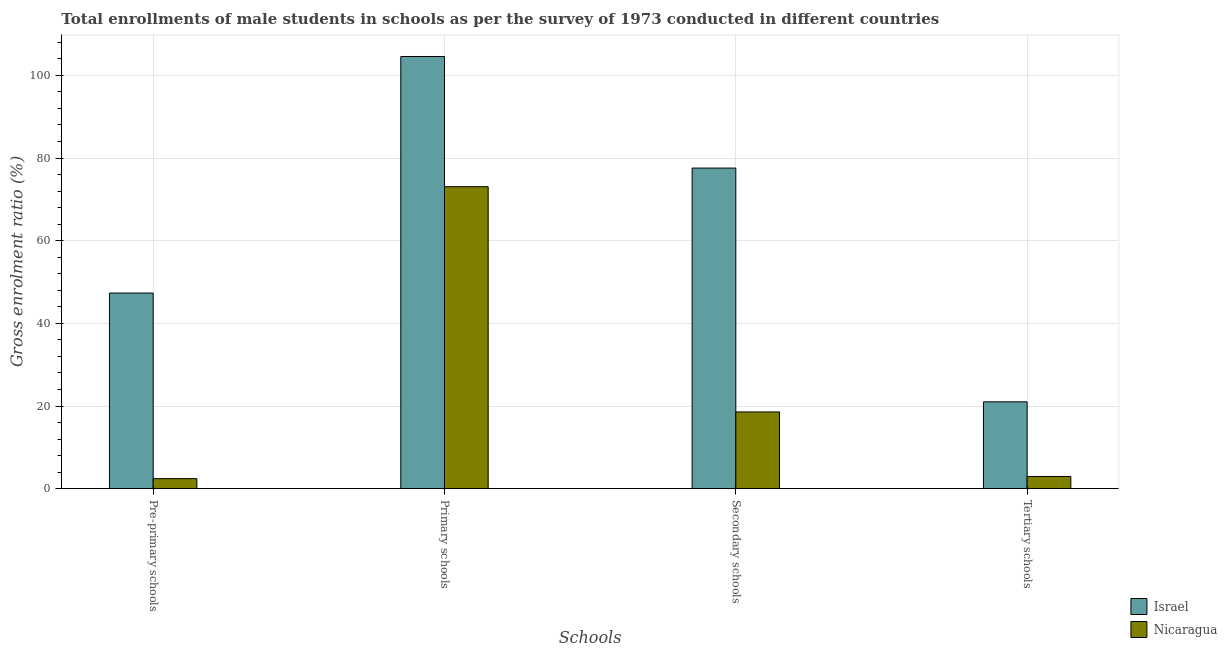How many different coloured bars are there?
Provide a succinct answer. 2. How many groups of bars are there?
Make the answer very short. 4. How many bars are there on the 1st tick from the left?
Your answer should be compact. 2. What is the label of the 1st group of bars from the left?
Your answer should be compact. Pre-primary schools. What is the gross enrolment ratio(male) in tertiary schools in Nicaragua?
Ensure brevity in your answer.  2.95. Across all countries, what is the maximum gross enrolment ratio(male) in primary schools?
Offer a terse response. 104.57. Across all countries, what is the minimum gross enrolment ratio(male) in primary schools?
Make the answer very short. 73.07. In which country was the gross enrolment ratio(male) in pre-primary schools maximum?
Offer a very short reply. Israel. In which country was the gross enrolment ratio(male) in secondary schools minimum?
Your answer should be compact. Nicaragua. What is the total gross enrolment ratio(male) in primary schools in the graph?
Provide a short and direct response. 177.64. What is the difference between the gross enrolment ratio(male) in pre-primary schools in Nicaragua and that in Israel?
Your response must be concise. -44.91. What is the difference between the gross enrolment ratio(male) in secondary schools in Nicaragua and the gross enrolment ratio(male) in pre-primary schools in Israel?
Ensure brevity in your answer.  -28.77. What is the average gross enrolment ratio(male) in primary schools per country?
Ensure brevity in your answer.  88.82. What is the difference between the gross enrolment ratio(male) in pre-primary schools and gross enrolment ratio(male) in tertiary schools in Nicaragua?
Offer a very short reply. -0.52. What is the ratio of the gross enrolment ratio(male) in pre-primary schools in Nicaragua to that in Israel?
Make the answer very short. 0.05. What is the difference between the highest and the second highest gross enrolment ratio(male) in pre-primary schools?
Provide a short and direct response. 44.91. What is the difference between the highest and the lowest gross enrolment ratio(male) in secondary schools?
Ensure brevity in your answer.  59.01. In how many countries, is the gross enrolment ratio(male) in primary schools greater than the average gross enrolment ratio(male) in primary schools taken over all countries?
Offer a terse response. 1. Is the sum of the gross enrolment ratio(male) in primary schools in Israel and Nicaragua greater than the maximum gross enrolment ratio(male) in secondary schools across all countries?
Your response must be concise. Yes. What does the 2nd bar from the left in Tertiary schools represents?
Give a very brief answer. Nicaragua. What does the 1st bar from the right in Pre-primary schools represents?
Your response must be concise. Nicaragua. Is it the case that in every country, the sum of the gross enrolment ratio(male) in pre-primary schools and gross enrolment ratio(male) in primary schools is greater than the gross enrolment ratio(male) in secondary schools?
Offer a very short reply. Yes. How many bars are there?
Your response must be concise. 8. How many countries are there in the graph?
Your answer should be very brief. 2. What is the difference between two consecutive major ticks on the Y-axis?
Give a very brief answer. 20. Are the values on the major ticks of Y-axis written in scientific E-notation?
Your response must be concise. No. Does the graph contain grids?
Offer a terse response. Yes. Where does the legend appear in the graph?
Ensure brevity in your answer.  Bottom right. How are the legend labels stacked?
Your response must be concise. Vertical. What is the title of the graph?
Offer a very short reply. Total enrollments of male students in schools as per the survey of 1973 conducted in different countries. Does "Liberia" appear as one of the legend labels in the graph?
Give a very brief answer. No. What is the label or title of the X-axis?
Offer a very short reply. Schools. What is the Gross enrolment ratio (%) in Israel in Pre-primary schools?
Offer a very short reply. 47.34. What is the Gross enrolment ratio (%) in Nicaragua in Pre-primary schools?
Offer a very short reply. 2.43. What is the Gross enrolment ratio (%) in Israel in Primary schools?
Your answer should be compact. 104.57. What is the Gross enrolment ratio (%) in Nicaragua in Primary schools?
Your answer should be compact. 73.07. What is the Gross enrolment ratio (%) of Israel in Secondary schools?
Your answer should be compact. 77.57. What is the Gross enrolment ratio (%) of Nicaragua in Secondary schools?
Keep it short and to the point. 18.57. What is the Gross enrolment ratio (%) in Israel in Tertiary schools?
Ensure brevity in your answer.  21.01. What is the Gross enrolment ratio (%) of Nicaragua in Tertiary schools?
Your answer should be very brief. 2.95. Across all Schools, what is the maximum Gross enrolment ratio (%) of Israel?
Offer a very short reply. 104.57. Across all Schools, what is the maximum Gross enrolment ratio (%) of Nicaragua?
Your answer should be very brief. 73.07. Across all Schools, what is the minimum Gross enrolment ratio (%) in Israel?
Provide a short and direct response. 21.01. Across all Schools, what is the minimum Gross enrolment ratio (%) of Nicaragua?
Ensure brevity in your answer.  2.43. What is the total Gross enrolment ratio (%) in Israel in the graph?
Give a very brief answer. 250.49. What is the total Gross enrolment ratio (%) in Nicaragua in the graph?
Provide a succinct answer. 97.02. What is the difference between the Gross enrolment ratio (%) in Israel in Pre-primary schools and that in Primary schools?
Provide a short and direct response. -57.23. What is the difference between the Gross enrolment ratio (%) in Nicaragua in Pre-primary schools and that in Primary schools?
Give a very brief answer. -70.64. What is the difference between the Gross enrolment ratio (%) in Israel in Pre-primary schools and that in Secondary schools?
Your answer should be very brief. -30.24. What is the difference between the Gross enrolment ratio (%) of Nicaragua in Pre-primary schools and that in Secondary schools?
Your response must be concise. -16.14. What is the difference between the Gross enrolment ratio (%) of Israel in Pre-primary schools and that in Tertiary schools?
Your answer should be compact. 26.32. What is the difference between the Gross enrolment ratio (%) in Nicaragua in Pre-primary schools and that in Tertiary schools?
Keep it short and to the point. -0.52. What is the difference between the Gross enrolment ratio (%) of Israel in Primary schools and that in Secondary schools?
Keep it short and to the point. 27. What is the difference between the Gross enrolment ratio (%) in Nicaragua in Primary schools and that in Secondary schools?
Give a very brief answer. 54.5. What is the difference between the Gross enrolment ratio (%) in Israel in Primary schools and that in Tertiary schools?
Your response must be concise. 83.56. What is the difference between the Gross enrolment ratio (%) of Nicaragua in Primary schools and that in Tertiary schools?
Offer a very short reply. 70.12. What is the difference between the Gross enrolment ratio (%) in Israel in Secondary schools and that in Tertiary schools?
Offer a very short reply. 56.56. What is the difference between the Gross enrolment ratio (%) of Nicaragua in Secondary schools and that in Tertiary schools?
Provide a succinct answer. 15.62. What is the difference between the Gross enrolment ratio (%) in Israel in Pre-primary schools and the Gross enrolment ratio (%) in Nicaragua in Primary schools?
Make the answer very short. -25.73. What is the difference between the Gross enrolment ratio (%) in Israel in Pre-primary schools and the Gross enrolment ratio (%) in Nicaragua in Secondary schools?
Your answer should be compact. 28.77. What is the difference between the Gross enrolment ratio (%) in Israel in Pre-primary schools and the Gross enrolment ratio (%) in Nicaragua in Tertiary schools?
Make the answer very short. 44.39. What is the difference between the Gross enrolment ratio (%) in Israel in Primary schools and the Gross enrolment ratio (%) in Nicaragua in Secondary schools?
Give a very brief answer. 86. What is the difference between the Gross enrolment ratio (%) in Israel in Primary schools and the Gross enrolment ratio (%) in Nicaragua in Tertiary schools?
Offer a very short reply. 101.62. What is the difference between the Gross enrolment ratio (%) of Israel in Secondary schools and the Gross enrolment ratio (%) of Nicaragua in Tertiary schools?
Your answer should be compact. 74.62. What is the average Gross enrolment ratio (%) in Israel per Schools?
Offer a very short reply. 62.62. What is the average Gross enrolment ratio (%) in Nicaragua per Schools?
Offer a terse response. 24.25. What is the difference between the Gross enrolment ratio (%) of Israel and Gross enrolment ratio (%) of Nicaragua in Pre-primary schools?
Make the answer very short. 44.91. What is the difference between the Gross enrolment ratio (%) of Israel and Gross enrolment ratio (%) of Nicaragua in Primary schools?
Provide a succinct answer. 31.5. What is the difference between the Gross enrolment ratio (%) of Israel and Gross enrolment ratio (%) of Nicaragua in Secondary schools?
Give a very brief answer. 59.01. What is the difference between the Gross enrolment ratio (%) in Israel and Gross enrolment ratio (%) in Nicaragua in Tertiary schools?
Ensure brevity in your answer.  18.06. What is the ratio of the Gross enrolment ratio (%) in Israel in Pre-primary schools to that in Primary schools?
Keep it short and to the point. 0.45. What is the ratio of the Gross enrolment ratio (%) of Israel in Pre-primary schools to that in Secondary schools?
Offer a very short reply. 0.61. What is the ratio of the Gross enrolment ratio (%) in Nicaragua in Pre-primary schools to that in Secondary schools?
Make the answer very short. 0.13. What is the ratio of the Gross enrolment ratio (%) in Israel in Pre-primary schools to that in Tertiary schools?
Offer a terse response. 2.25. What is the ratio of the Gross enrolment ratio (%) of Nicaragua in Pre-primary schools to that in Tertiary schools?
Offer a terse response. 0.82. What is the ratio of the Gross enrolment ratio (%) of Israel in Primary schools to that in Secondary schools?
Your answer should be compact. 1.35. What is the ratio of the Gross enrolment ratio (%) in Nicaragua in Primary schools to that in Secondary schools?
Provide a succinct answer. 3.94. What is the ratio of the Gross enrolment ratio (%) of Israel in Primary schools to that in Tertiary schools?
Ensure brevity in your answer.  4.98. What is the ratio of the Gross enrolment ratio (%) in Nicaragua in Primary schools to that in Tertiary schools?
Offer a terse response. 24.76. What is the ratio of the Gross enrolment ratio (%) of Israel in Secondary schools to that in Tertiary schools?
Provide a succinct answer. 3.69. What is the ratio of the Gross enrolment ratio (%) of Nicaragua in Secondary schools to that in Tertiary schools?
Ensure brevity in your answer.  6.29. What is the difference between the highest and the second highest Gross enrolment ratio (%) of Israel?
Offer a terse response. 27. What is the difference between the highest and the second highest Gross enrolment ratio (%) of Nicaragua?
Provide a succinct answer. 54.5. What is the difference between the highest and the lowest Gross enrolment ratio (%) of Israel?
Provide a short and direct response. 83.56. What is the difference between the highest and the lowest Gross enrolment ratio (%) of Nicaragua?
Ensure brevity in your answer.  70.64. 